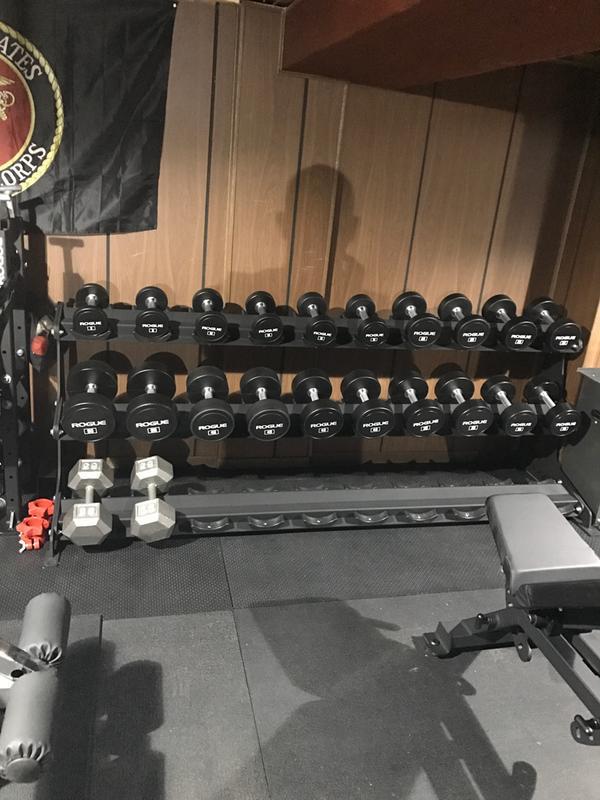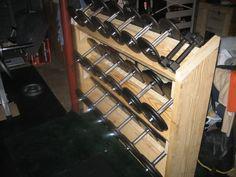The first image is the image on the left, the second image is the image on the right. Given the left and right images, does the statement "At least some of the weights in one of the pictures have red on them." hold true? Answer yes or no. No. 